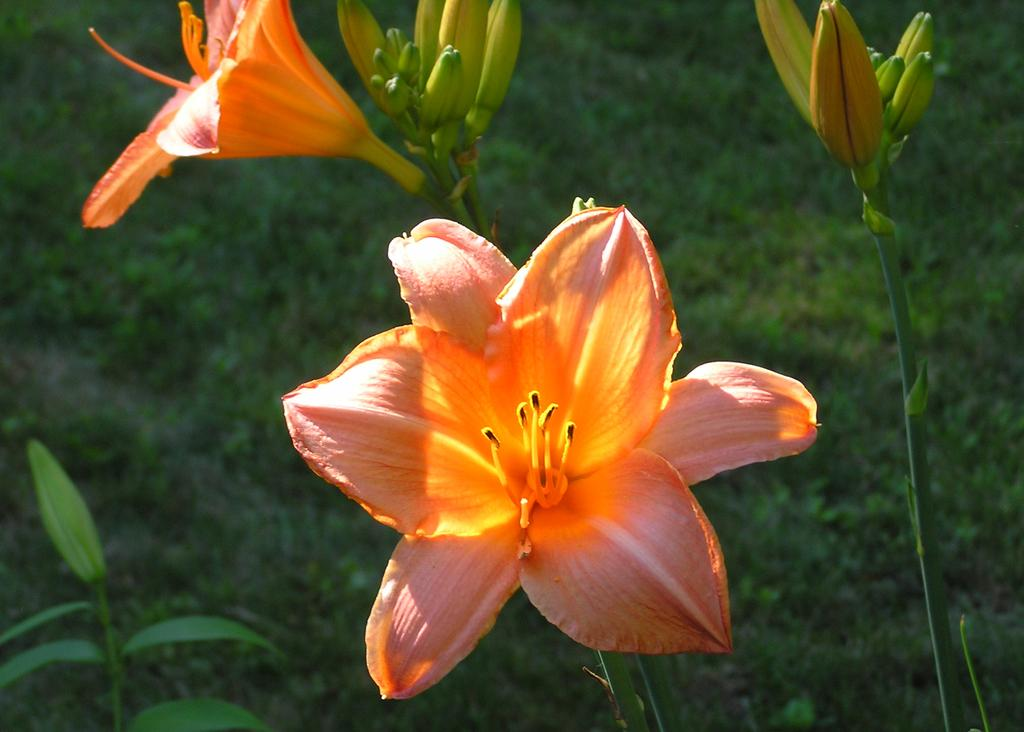What types of living organisms can be seen in the image? Plants and flowers are visible in the image. Can you describe the plants in the image? There are flowers and small plants visible in the image. How would you describe the overall appearance of the image? The image appears to be blurred. What type of game is being played in the image? There is no game present in the image; it features plants and flowers. How many steps does the mother take in the image? There is no mother or steps visible in the image. 